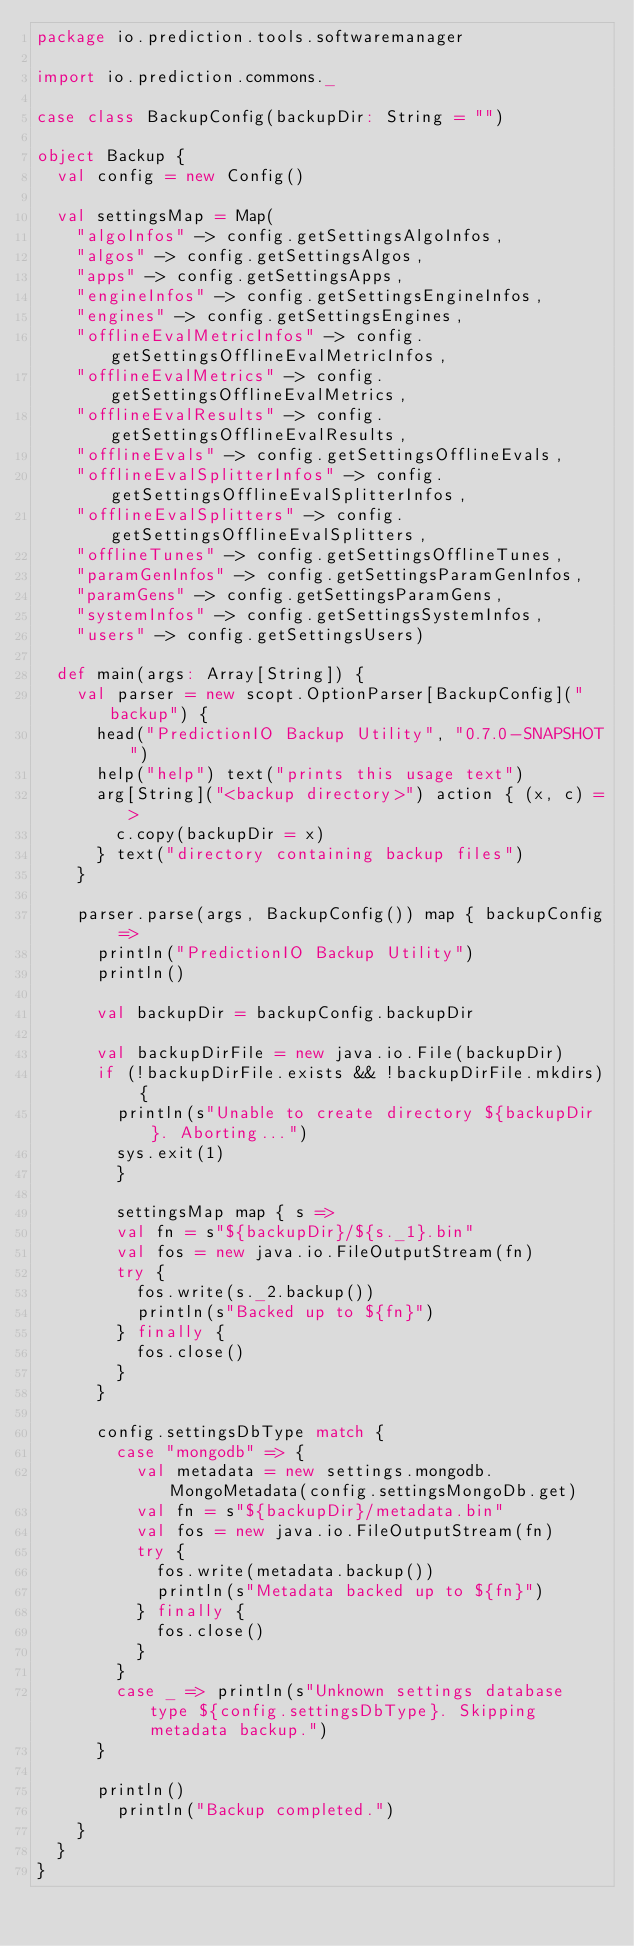<code> <loc_0><loc_0><loc_500><loc_500><_Scala_>package io.prediction.tools.softwaremanager

import io.prediction.commons._

case class BackupConfig(backupDir: String = "")

object Backup {
  val config = new Config()

  val settingsMap = Map(
    "algoInfos" -> config.getSettingsAlgoInfos,
    "algos" -> config.getSettingsAlgos,
    "apps" -> config.getSettingsApps,
    "engineInfos" -> config.getSettingsEngineInfos,
    "engines" -> config.getSettingsEngines,
    "offlineEvalMetricInfos" -> config.getSettingsOfflineEvalMetricInfos,
    "offlineEvalMetrics" -> config.getSettingsOfflineEvalMetrics,
    "offlineEvalResults" -> config.getSettingsOfflineEvalResults,
    "offlineEvals" -> config.getSettingsOfflineEvals,
    "offlineEvalSplitterInfos" -> config.getSettingsOfflineEvalSplitterInfos,
    "offlineEvalSplitters" -> config.getSettingsOfflineEvalSplitters,
    "offlineTunes" -> config.getSettingsOfflineTunes,
    "paramGenInfos" -> config.getSettingsParamGenInfos,
    "paramGens" -> config.getSettingsParamGens,
    "systemInfos" -> config.getSettingsSystemInfos,
    "users" -> config.getSettingsUsers)

  def main(args: Array[String]) {
    val parser = new scopt.OptionParser[BackupConfig]("backup") {
      head("PredictionIO Backup Utility", "0.7.0-SNAPSHOT")
      help("help") text("prints this usage text")
      arg[String]("<backup directory>") action { (x, c) =>
        c.copy(backupDir = x)
      } text("directory containing backup files")
    }

    parser.parse(args, BackupConfig()) map { backupConfig =>
      println("PredictionIO Backup Utility")
      println()

      val backupDir = backupConfig.backupDir

      val backupDirFile = new java.io.File(backupDir)
      if (!backupDirFile.exists && !backupDirFile.mkdirs) {
        println(s"Unable to create directory ${backupDir}. Aborting...")
        sys.exit(1)
    	}

    	settingsMap map { s =>
        val fn = s"${backupDir}/${s._1}.bin"
        val fos = new java.io.FileOutputStream(fn)
        try {
          fos.write(s._2.backup())
          println(s"Backed up to ${fn}")
        } finally {
          fos.close()
        }
      }

      config.settingsDbType match {
        case "mongodb" => {
          val metadata = new settings.mongodb.MongoMetadata(config.settingsMongoDb.get)
          val fn = s"${backupDir}/metadata.bin"
          val fos = new java.io.FileOutputStream(fn)
          try {
            fos.write(metadata.backup())
            println(s"Metadata backed up to ${fn}")
          } finally {
            fos.close()
          }
        }
        case _ => println(s"Unknown settings database type ${config.settingsDbType}. Skipping metadata backup.")
      }

      println()
    	println("Backup completed.")
    }
  }
}
</code> 